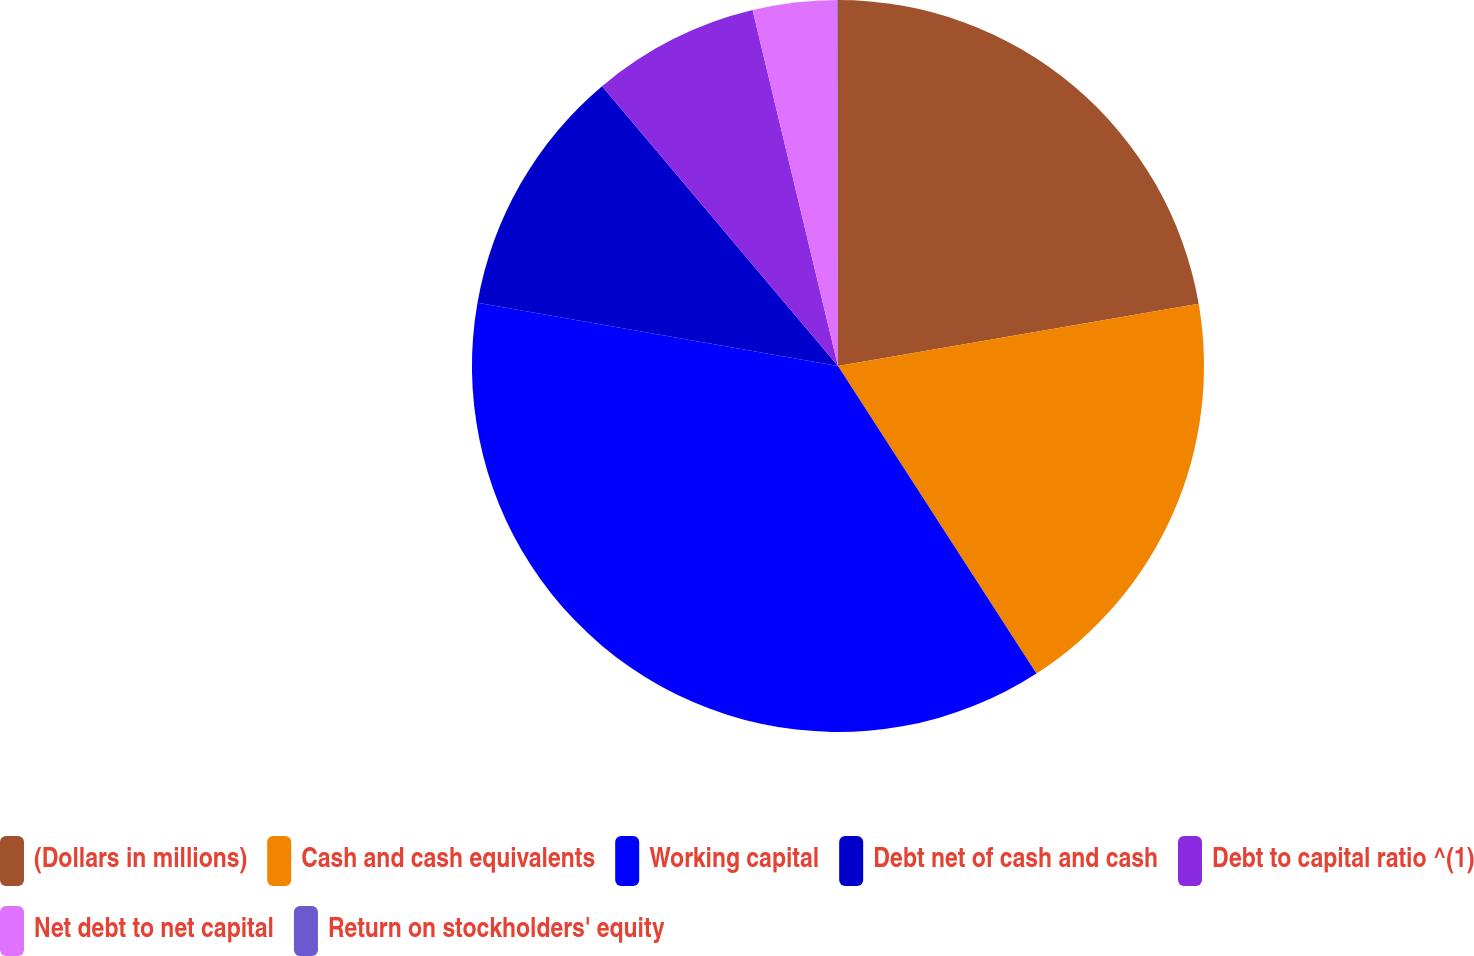Convert chart. <chart><loc_0><loc_0><loc_500><loc_500><pie_chart><fcel>(Dollars in millions)<fcel>Cash and cash equivalents<fcel>Working capital<fcel>Debt net of cash and cash<fcel>Debt to capital ratio ^(1)<fcel>Net debt to net capital<fcel>Return on stockholders' equity<nl><fcel>22.28%<fcel>18.6%<fcel>36.88%<fcel>11.09%<fcel>7.4%<fcel>3.72%<fcel>0.03%<nl></chart> 